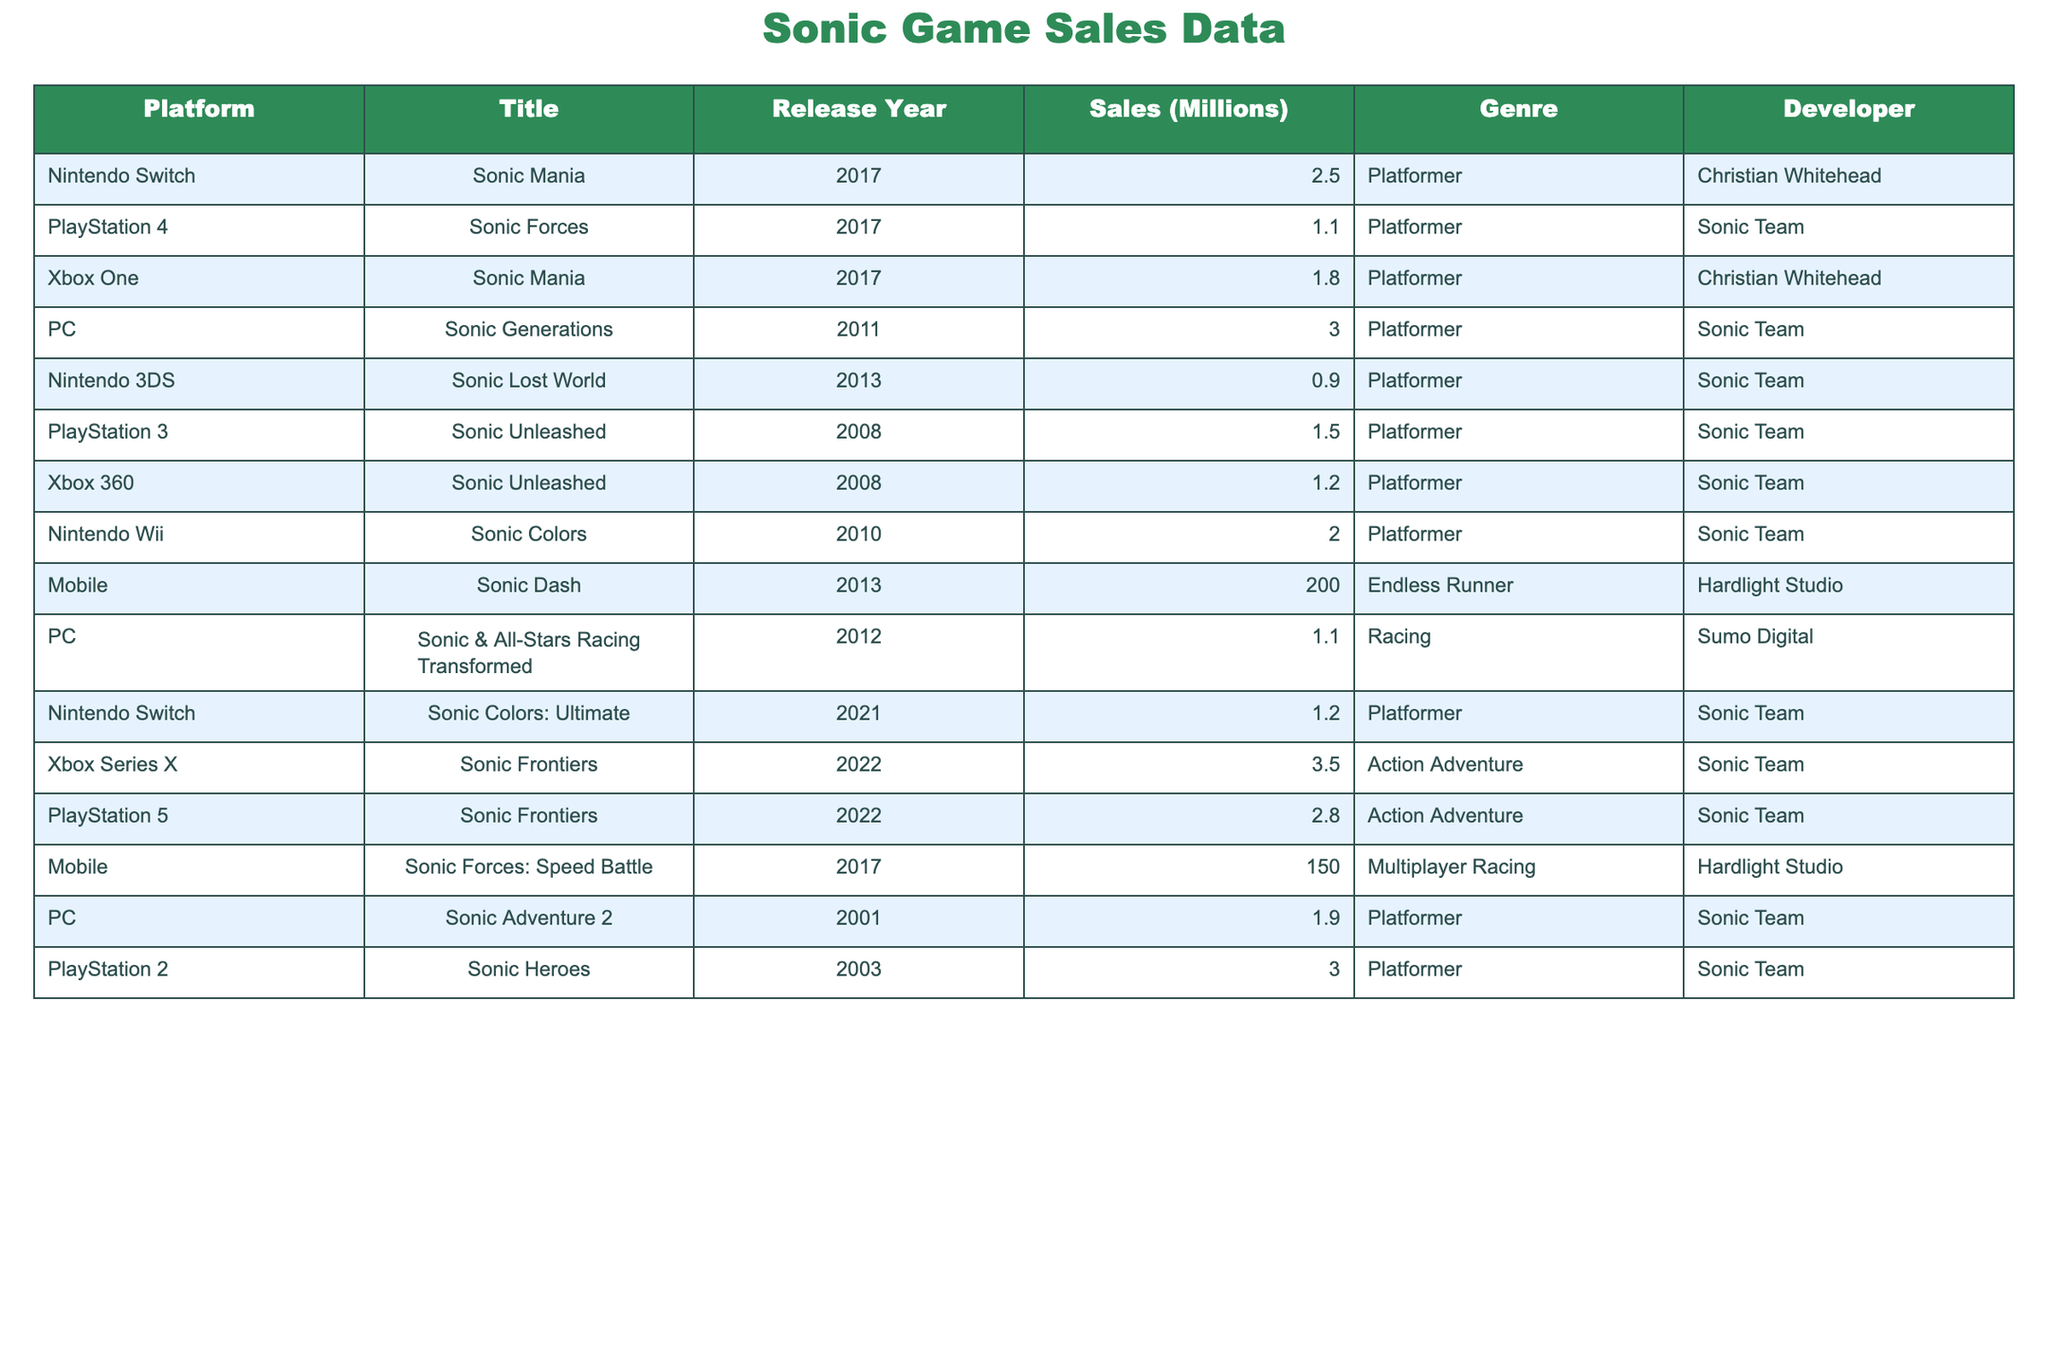What is the title of the highest-selling Sonic game? The highest-selling Sonic game listed in the table is "Sonic Dash," which has sales of 200 million units.
Answer: Sonic Dash How many sales did "Sonic Forces" achieve on the PlayStation 4? "Sonic Forces" achieved sales of 1.1 million units on the PlayStation 4, as noted in the table.
Answer: 1.1 million What is the total sales for Sonic games on mobile platforms? The total sales for mobile Sonic games are 200 million (Sonic Dash) + 150 million (Sonic Forces: Speed Battle) = 350 million units.
Answer: 350 million Which platform had the highest sales for "Sonic Frontiers"? "Sonic Frontiers" had the highest sales on Xbox Series X with 3.5 million units sold.
Answer: Xbox Series X How many Sonic games were released on the Nintendo Switch? There are three Sonic games listed for the Nintendo Switch: "Sonic Mania," "Sonic Colors: Ultimate," and "Sonic Colors."
Answer: 3 What is the average sales figure of Sonic games on PC? The sales for PC games are: Sonic Generations (3.0), Sonic & All-Stars Racing Transformed (1.1), and Sonic Adventure 2 (1.9). The average is (3.0 + 1.1 + 1.9) / 3 = 2.0 million.
Answer: 2.0 million Did any Sonic game released on the Nintendo 3DS reach sales above 1 million? "Sonic Lost World," released on the Nintendo 3DS, achieved sales of 0.9 million, which is below 1 million.
Answer: No What is the difference in sales between "Sonic Colors" on the Nintendo Wii and "Sonic Forces" on the PlayStation 4? "Sonic Colors" sells 2.0 million units, while "Sonic Forces" sells 1.1 million units. The difference is 2.0 - 1.1 = 0.9 million units.
Answer: 0.9 million Which genre of Sonic games has the highest sales total? The Endless Runner genre with "Sonic Dash" (200 million) and Multiplayer Racing with "Sonic Forces: Speed Battle" (150 million) totals 350 million, which is higher than other genres' totals.
Answer: Endless Runner How does the sales performance of "Sonic Unleashed" compare between PlayStation 3 and Xbox 360? "Sonic Unleashed" sold 1.5 million on PlayStation 3 and 1.2 million on Xbox 360. The PlayStation 3 version outperformed the Xbox 360 version by 0.3 million units.
Answer: PlayStation 3 What proportion of Sonic games have sales over 1 million? There are 9 games in total mentioned, with 7 games selling over 1 million units. The proportion is 7/9 ≈ 0.78, or about 78%.
Answer: 78% 